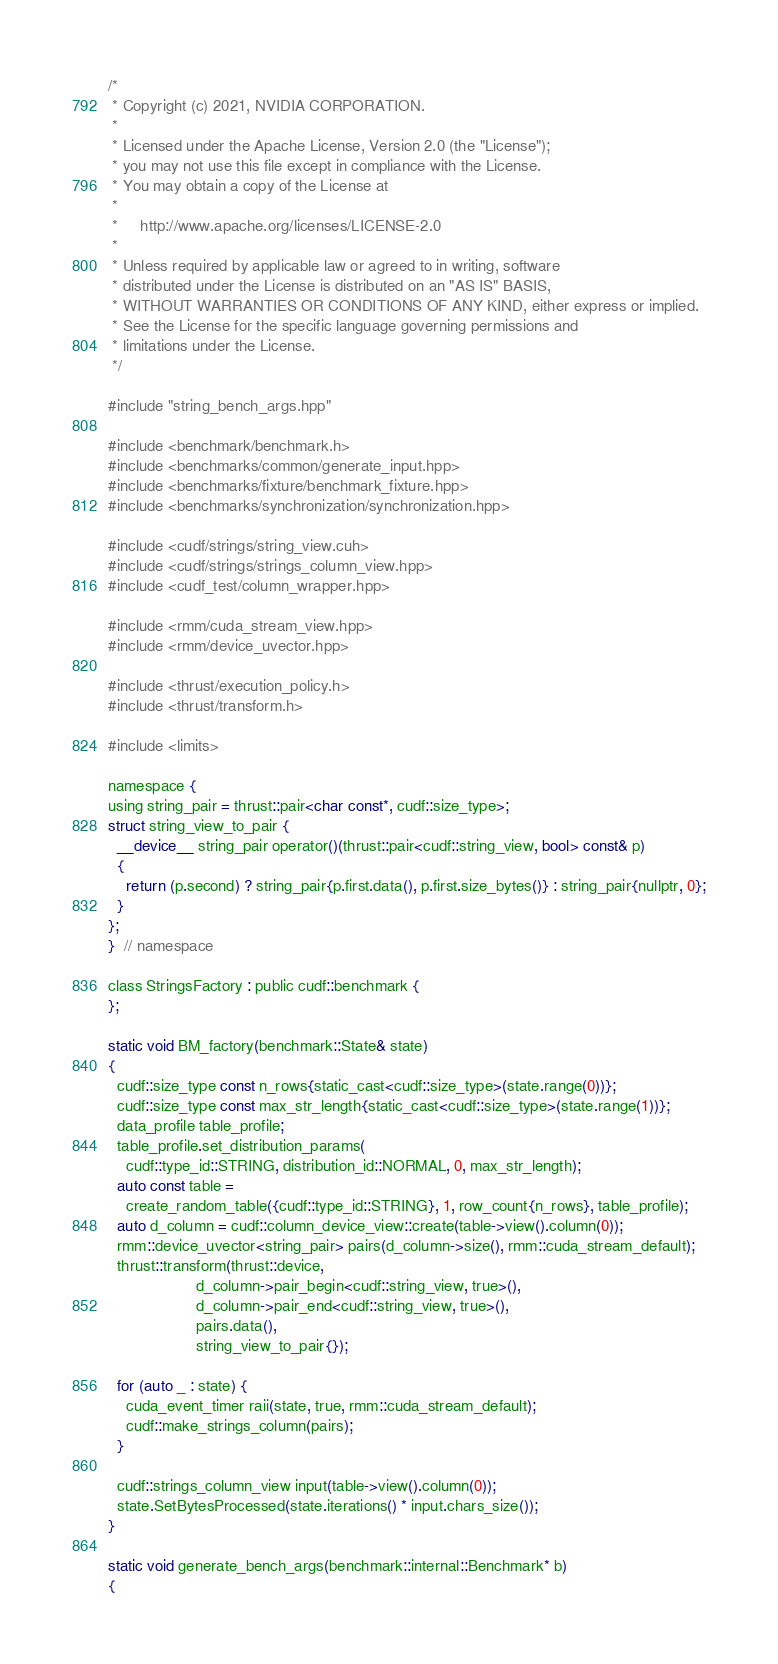Convert code to text. <code><loc_0><loc_0><loc_500><loc_500><_Cuda_>/*
 * Copyright (c) 2021, NVIDIA CORPORATION.
 *
 * Licensed under the Apache License, Version 2.0 (the "License");
 * you may not use this file except in compliance with the License.
 * You may obtain a copy of the License at
 *
 *     http://www.apache.org/licenses/LICENSE-2.0
 *
 * Unless required by applicable law or agreed to in writing, software
 * distributed under the License is distributed on an "AS IS" BASIS,
 * WITHOUT WARRANTIES OR CONDITIONS OF ANY KIND, either express or implied.
 * See the License for the specific language governing permissions and
 * limitations under the License.
 */

#include "string_bench_args.hpp"

#include <benchmark/benchmark.h>
#include <benchmarks/common/generate_input.hpp>
#include <benchmarks/fixture/benchmark_fixture.hpp>
#include <benchmarks/synchronization/synchronization.hpp>

#include <cudf/strings/string_view.cuh>
#include <cudf/strings/strings_column_view.hpp>
#include <cudf_test/column_wrapper.hpp>

#include <rmm/cuda_stream_view.hpp>
#include <rmm/device_uvector.hpp>

#include <thrust/execution_policy.h>
#include <thrust/transform.h>

#include <limits>

namespace {
using string_pair = thrust::pair<char const*, cudf::size_type>;
struct string_view_to_pair {
  __device__ string_pair operator()(thrust::pair<cudf::string_view, bool> const& p)
  {
    return (p.second) ? string_pair{p.first.data(), p.first.size_bytes()} : string_pair{nullptr, 0};
  }
};
}  // namespace

class StringsFactory : public cudf::benchmark {
};

static void BM_factory(benchmark::State& state)
{
  cudf::size_type const n_rows{static_cast<cudf::size_type>(state.range(0))};
  cudf::size_type const max_str_length{static_cast<cudf::size_type>(state.range(1))};
  data_profile table_profile;
  table_profile.set_distribution_params(
    cudf::type_id::STRING, distribution_id::NORMAL, 0, max_str_length);
  auto const table =
    create_random_table({cudf::type_id::STRING}, 1, row_count{n_rows}, table_profile);
  auto d_column = cudf::column_device_view::create(table->view().column(0));
  rmm::device_uvector<string_pair> pairs(d_column->size(), rmm::cuda_stream_default);
  thrust::transform(thrust::device,
                    d_column->pair_begin<cudf::string_view, true>(),
                    d_column->pair_end<cudf::string_view, true>(),
                    pairs.data(),
                    string_view_to_pair{});

  for (auto _ : state) {
    cuda_event_timer raii(state, true, rmm::cuda_stream_default);
    cudf::make_strings_column(pairs);
  }

  cudf::strings_column_view input(table->view().column(0));
  state.SetBytesProcessed(state.iterations() * input.chars_size());
}

static void generate_bench_args(benchmark::internal::Benchmark* b)
{</code> 